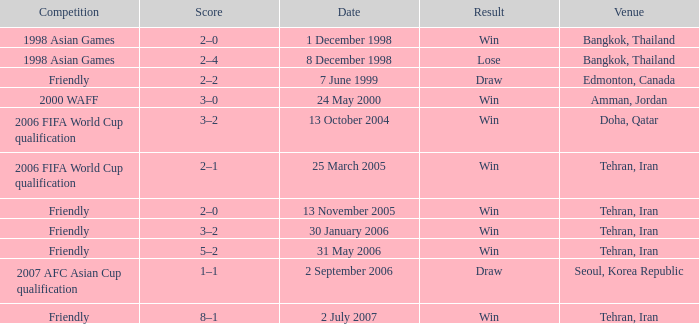What was the competition on 13 November 2005? Friendly. 